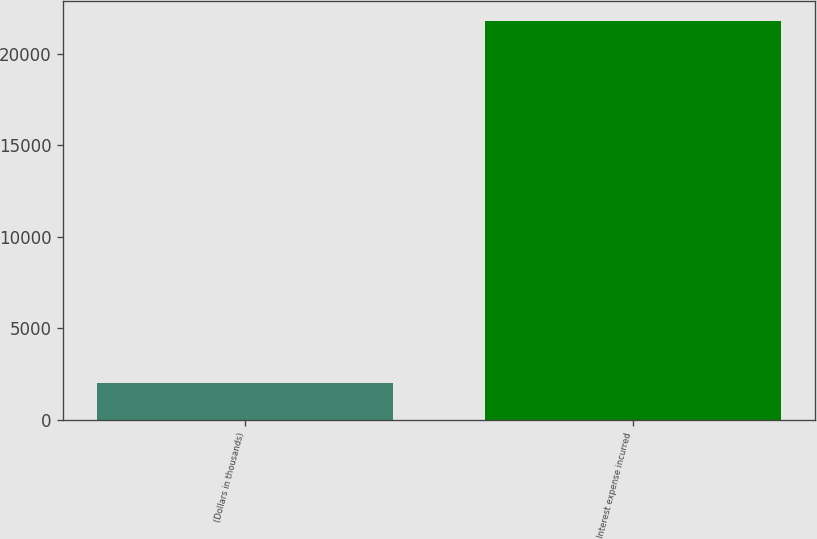Convert chart to OTSL. <chart><loc_0><loc_0><loc_500><loc_500><bar_chart><fcel>(Dollars in thousands)<fcel>Interest expense incurred<nl><fcel>2014<fcel>21818<nl></chart> 